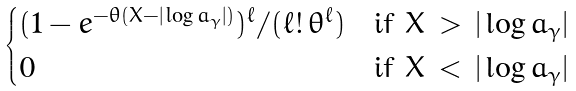Convert formula to latex. <formula><loc_0><loc_0><loc_500><loc_500>\begin{cases} ( 1 - e ^ { - \theta ( X - | \log a _ { \gamma } | ) } ) ^ { \ell } / ( \ell ! \, \theta ^ { \ell } ) & \text {if } X \, > \, | \log a _ { \gamma } | \\ 0 & \text {if } X \, < \, | \log a _ { \gamma } | \end{cases}</formula> 